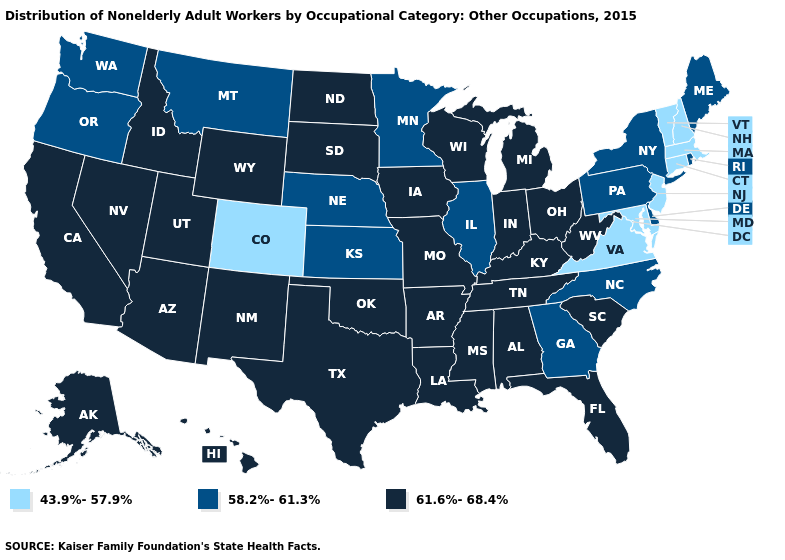Which states have the lowest value in the USA?
Concise answer only. Colorado, Connecticut, Maryland, Massachusetts, New Hampshire, New Jersey, Vermont, Virginia. Does Connecticut have a lower value than Maryland?
Quick response, please. No. Is the legend a continuous bar?
Keep it brief. No. Name the states that have a value in the range 43.9%-57.9%?
Be succinct. Colorado, Connecticut, Maryland, Massachusetts, New Hampshire, New Jersey, Vermont, Virginia. Name the states that have a value in the range 58.2%-61.3%?
Quick response, please. Delaware, Georgia, Illinois, Kansas, Maine, Minnesota, Montana, Nebraska, New York, North Carolina, Oregon, Pennsylvania, Rhode Island, Washington. Does Kentucky have a lower value than Mississippi?
Short answer required. No. Name the states that have a value in the range 58.2%-61.3%?
Give a very brief answer. Delaware, Georgia, Illinois, Kansas, Maine, Minnesota, Montana, Nebraska, New York, North Carolina, Oregon, Pennsylvania, Rhode Island, Washington. What is the highest value in the South ?
Short answer required. 61.6%-68.4%. Among the states that border Oklahoma , does Kansas have the lowest value?
Short answer required. No. Is the legend a continuous bar?
Answer briefly. No. Among the states that border Nevada , which have the highest value?
Be succinct. Arizona, California, Idaho, Utah. What is the value of Tennessee?
Concise answer only. 61.6%-68.4%. Name the states that have a value in the range 43.9%-57.9%?
Write a very short answer. Colorado, Connecticut, Maryland, Massachusetts, New Hampshire, New Jersey, Vermont, Virginia. Which states have the highest value in the USA?
Write a very short answer. Alabama, Alaska, Arizona, Arkansas, California, Florida, Hawaii, Idaho, Indiana, Iowa, Kentucky, Louisiana, Michigan, Mississippi, Missouri, Nevada, New Mexico, North Dakota, Ohio, Oklahoma, South Carolina, South Dakota, Tennessee, Texas, Utah, West Virginia, Wisconsin, Wyoming. Does Massachusetts have the lowest value in the USA?
Keep it brief. Yes. 